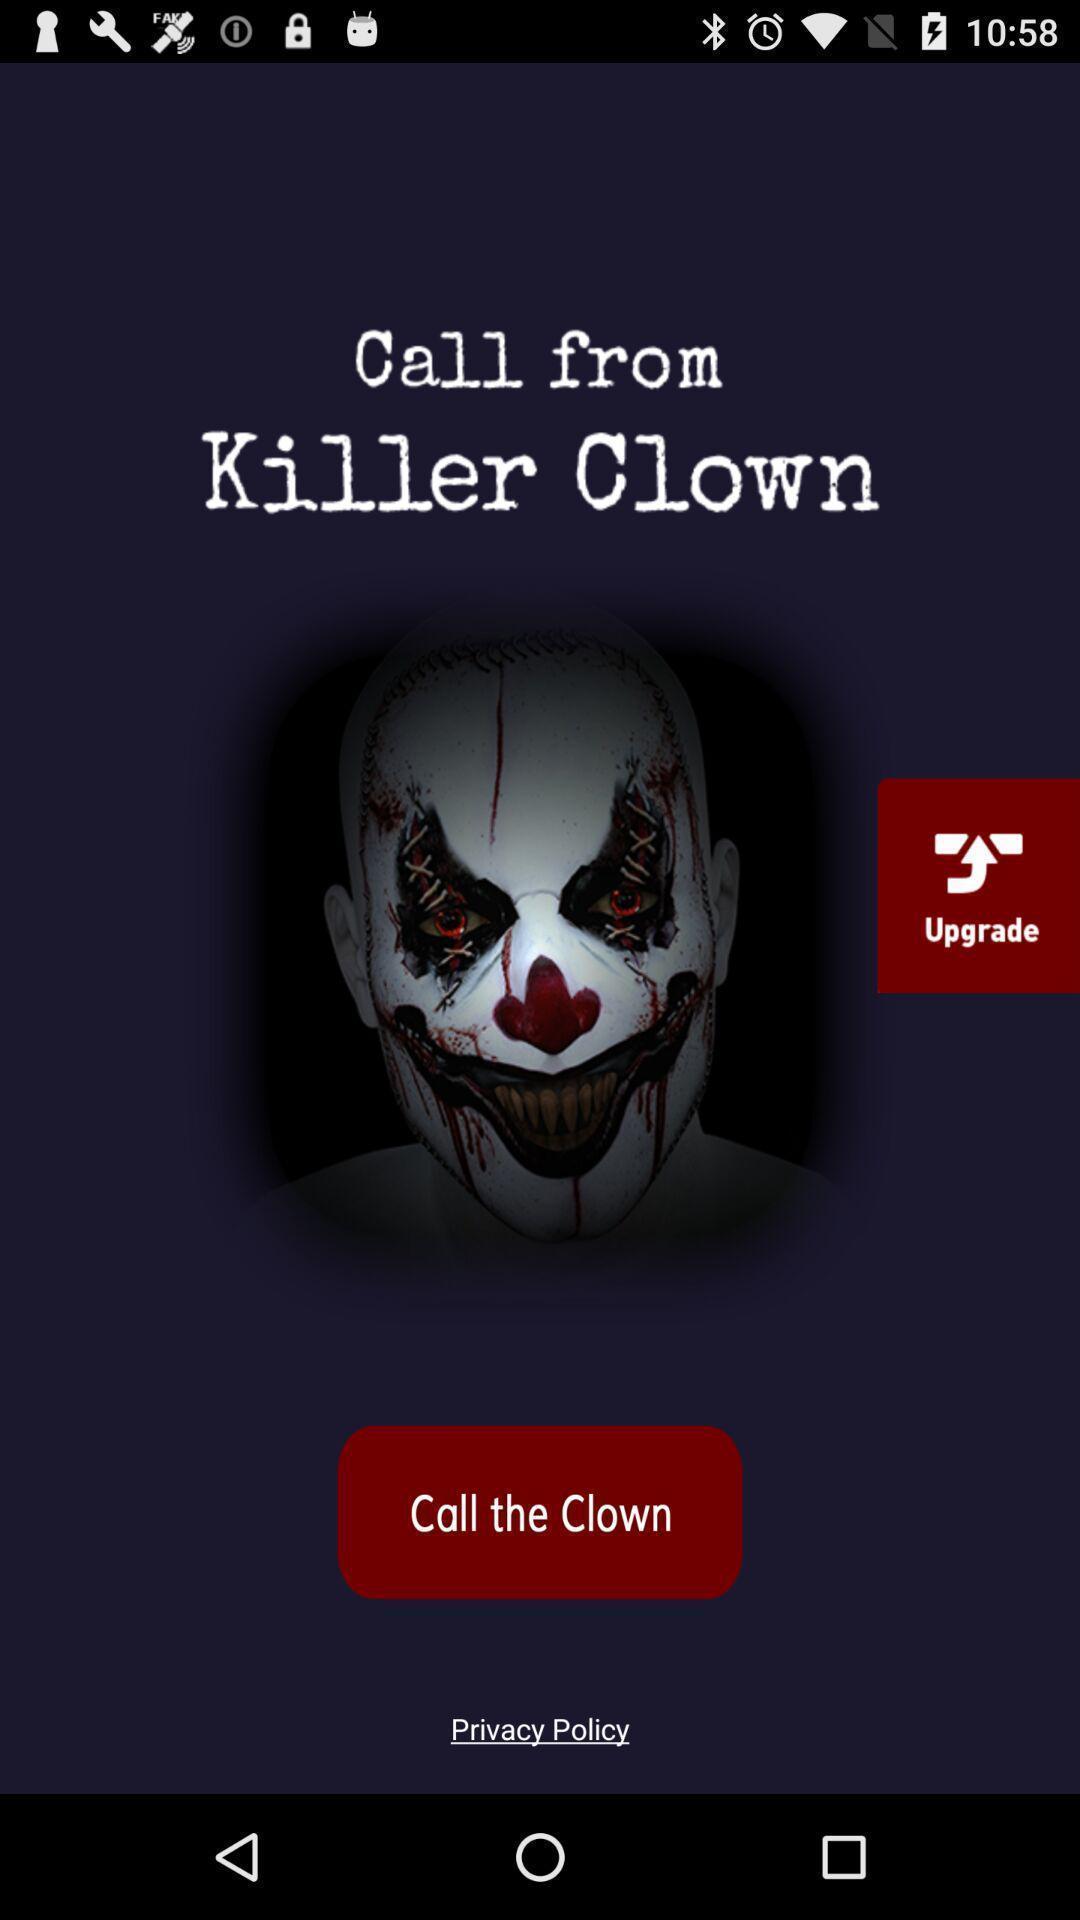Provide a textual representation of this image. Page displaying an option of call the clown. 